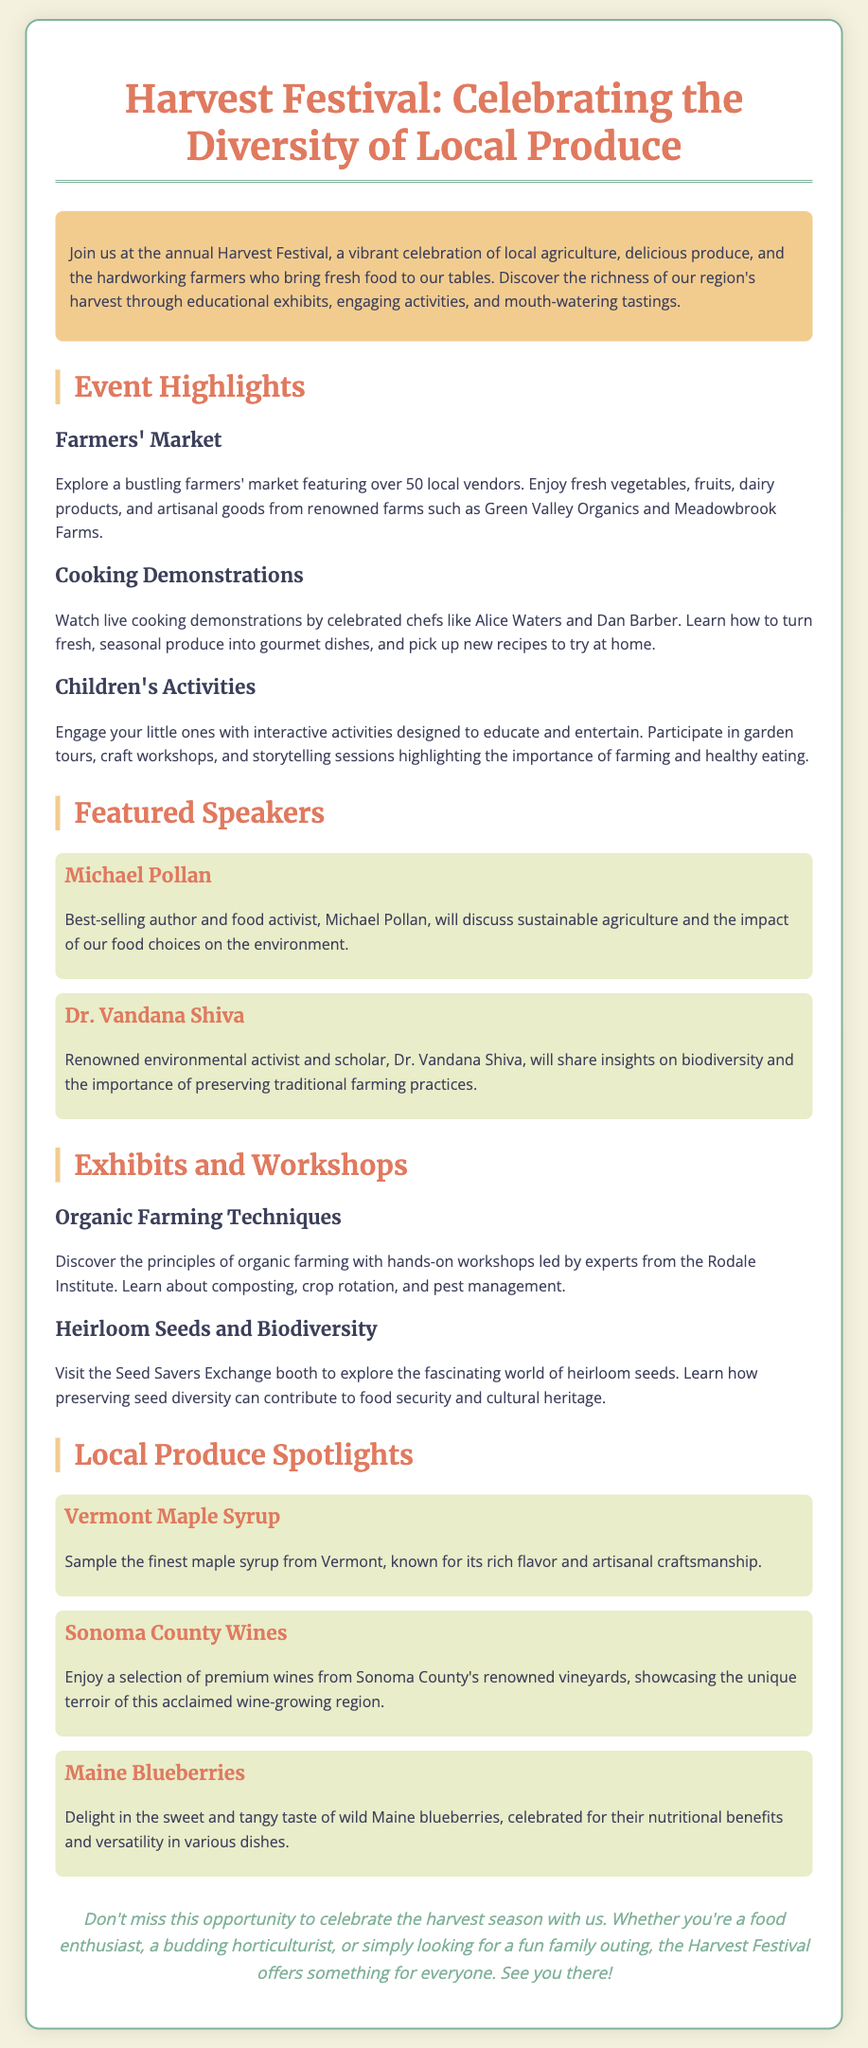What is the title of the event? The title of the event is mentioned at the beginning of the document.
Answer: Harvest Festival: Celebrating the Diversity of Local Produce How many local vendors are featured at the farmers' market? The number of vendors at the farmers' market is stated in the event highlights section.
Answer: over 50 Who is one of the celebrated chefs performing cooking demonstrations? The names of the chefs participating in cooking demonstrations are provided in the highlights section.
Answer: Alice Waters What will Michael Pollan discuss at the festival? The content of Michael Pollan's discussion is detailed in the featured speakers section.
Answer: sustainable agriculture What type of activities are included for children? The document lists specific types of activities designed for children under the children's activities section.
Answer: interactive activities Which heirloom seeds organization is mentioned in the document? The organization focused on heirloom seeds is referenced in the exhibits and workshops section.
Answer: Seed Savers Exchange What local produce is highlighted from Vermont? The document includes specific examples of local produce in the local produce spotlights section.
Answer: Vermont Maple Syrup Which region's wines are showcased at the festival? The region known for its wines is specified in the local produce spotlights section.
Answer: Sonoma County What is emphasized as a benefit of preserving heirloom seeds? The importance of preserving seed diversity is discussed in the context of heirloom seeds.
Answer: food security 